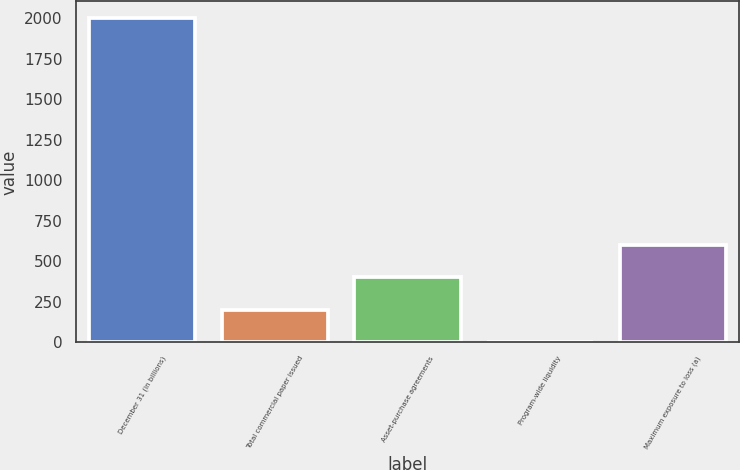<chart> <loc_0><loc_0><loc_500><loc_500><bar_chart><fcel>December 31 (in billions)<fcel>Total commercial paper issued<fcel>Asset-purchase agreements<fcel>Program-wide liquidity<fcel>Maximum exposure to loss (a)<nl><fcel>2005<fcel>201.4<fcel>401.8<fcel>1<fcel>602.2<nl></chart> 